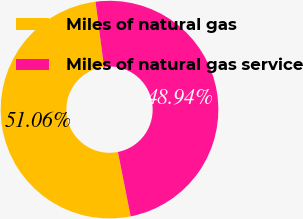<chart> <loc_0><loc_0><loc_500><loc_500><pie_chart><fcel>Miles of natural gas<fcel>Miles of natural gas service<nl><fcel>51.06%<fcel>48.94%<nl></chart> 